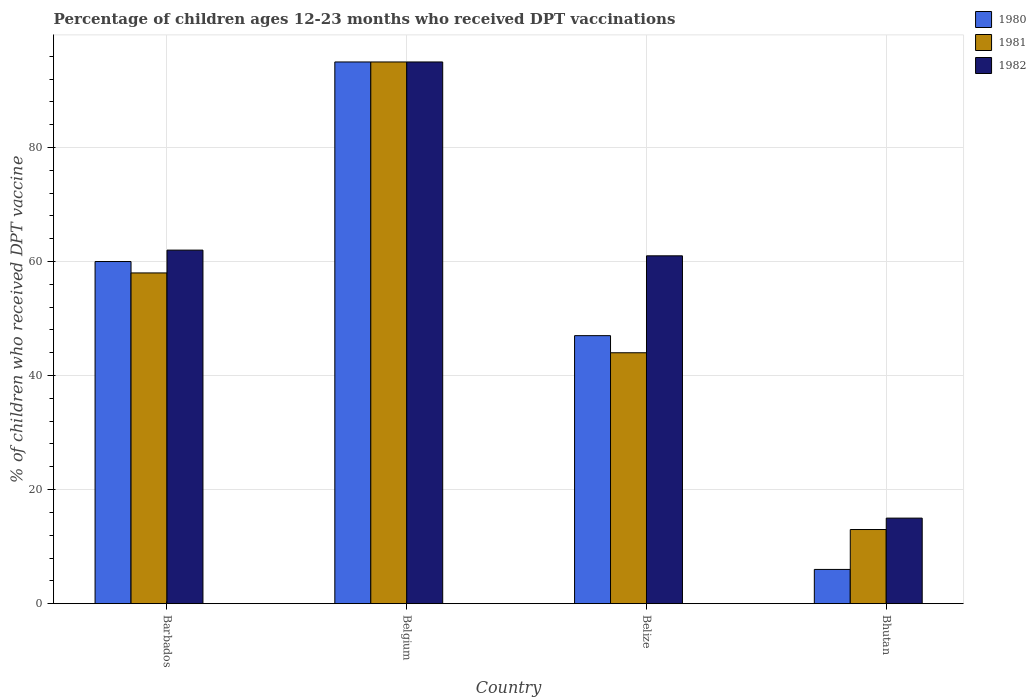How many different coloured bars are there?
Give a very brief answer. 3. Are the number of bars per tick equal to the number of legend labels?
Offer a very short reply. Yes. How many bars are there on the 3rd tick from the right?
Ensure brevity in your answer.  3. What is the label of the 1st group of bars from the left?
Offer a terse response. Barbados. What is the percentage of children who received DPT vaccination in 1981 in Belgium?
Offer a very short reply. 95. In which country was the percentage of children who received DPT vaccination in 1981 minimum?
Give a very brief answer. Bhutan. What is the total percentage of children who received DPT vaccination in 1981 in the graph?
Ensure brevity in your answer.  210. What is the difference between the percentage of children who received DPT vaccination in 1982 in Belgium and that in Bhutan?
Keep it short and to the point. 80. What is the difference between the percentage of children who received DPT vaccination in 1981 in Bhutan and the percentage of children who received DPT vaccination in 1980 in Belgium?
Provide a short and direct response. -82. What is the average percentage of children who received DPT vaccination in 1980 per country?
Make the answer very short. 52. What is the difference between the percentage of children who received DPT vaccination of/in 1981 and percentage of children who received DPT vaccination of/in 1982 in Belize?
Keep it short and to the point. -17. What is the ratio of the percentage of children who received DPT vaccination in 1982 in Barbados to that in Belgium?
Your answer should be very brief. 0.65. Is the percentage of children who received DPT vaccination in 1982 in Belgium less than that in Bhutan?
Provide a succinct answer. No. Is the difference between the percentage of children who received DPT vaccination in 1981 in Barbados and Bhutan greater than the difference between the percentage of children who received DPT vaccination in 1982 in Barbados and Bhutan?
Provide a short and direct response. No. What does the 2nd bar from the left in Bhutan represents?
Give a very brief answer. 1981. What does the 2nd bar from the right in Belize represents?
Ensure brevity in your answer.  1981. Is it the case that in every country, the sum of the percentage of children who received DPT vaccination in 1980 and percentage of children who received DPT vaccination in 1982 is greater than the percentage of children who received DPT vaccination in 1981?
Provide a short and direct response. Yes. How many bars are there?
Ensure brevity in your answer.  12. What is the difference between two consecutive major ticks on the Y-axis?
Provide a short and direct response. 20. Are the values on the major ticks of Y-axis written in scientific E-notation?
Offer a very short reply. No. Does the graph contain any zero values?
Provide a short and direct response. No. How are the legend labels stacked?
Make the answer very short. Vertical. What is the title of the graph?
Provide a succinct answer. Percentage of children ages 12-23 months who received DPT vaccinations. What is the label or title of the Y-axis?
Your response must be concise. % of children who received DPT vaccine. What is the % of children who received DPT vaccine in 1980 in Barbados?
Your answer should be very brief. 60. What is the % of children who received DPT vaccine in 1980 in Belgium?
Your response must be concise. 95. What is the % of children who received DPT vaccine of 1982 in Belgium?
Your response must be concise. 95. What is the % of children who received DPT vaccine in 1982 in Belize?
Provide a succinct answer. 61. What is the % of children who received DPT vaccine in 1980 in Bhutan?
Provide a succinct answer. 6. What is the % of children who received DPT vaccine in 1981 in Bhutan?
Offer a very short reply. 13. What is the % of children who received DPT vaccine in 1982 in Bhutan?
Provide a succinct answer. 15. Across all countries, what is the maximum % of children who received DPT vaccine in 1980?
Ensure brevity in your answer.  95. Across all countries, what is the minimum % of children who received DPT vaccine of 1980?
Ensure brevity in your answer.  6. Across all countries, what is the minimum % of children who received DPT vaccine of 1982?
Provide a succinct answer. 15. What is the total % of children who received DPT vaccine of 1980 in the graph?
Offer a terse response. 208. What is the total % of children who received DPT vaccine in 1981 in the graph?
Your response must be concise. 210. What is the total % of children who received DPT vaccine in 1982 in the graph?
Your answer should be compact. 233. What is the difference between the % of children who received DPT vaccine of 1980 in Barbados and that in Belgium?
Give a very brief answer. -35. What is the difference between the % of children who received DPT vaccine in 1981 in Barbados and that in Belgium?
Keep it short and to the point. -37. What is the difference between the % of children who received DPT vaccine of 1982 in Barbados and that in Belgium?
Provide a short and direct response. -33. What is the difference between the % of children who received DPT vaccine in 1980 in Barbados and that in Belize?
Provide a succinct answer. 13. What is the difference between the % of children who received DPT vaccine in 1981 in Barbados and that in Belize?
Keep it short and to the point. 14. What is the difference between the % of children who received DPT vaccine of 1980 in Barbados and that in Bhutan?
Make the answer very short. 54. What is the difference between the % of children who received DPT vaccine in 1981 in Belgium and that in Belize?
Provide a succinct answer. 51. What is the difference between the % of children who received DPT vaccine of 1980 in Belgium and that in Bhutan?
Make the answer very short. 89. What is the difference between the % of children who received DPT vaccine in 1981 in Belgium and that in Bhutan?
Your answer should be compact. 82. What is the difference between the % of children who received DPT vaccine of 1980 in Barbados and the % of children who received DPT vaccine of 1981 in Belgium?
Your response must be concise. -35. What is the difference between the % of children who received DPT vaccine of 1980 in Barbados and the % of children who received DPT vaccine of 1982 in Belgium?
Offer a terse response. -35. What is the difference between the % of children who received DPT vaccine of 1981 in Barbados and the % of children who received DPT vaccine of 1982 in Belgium?
Offer a very short reply. -37. What is the difference between the % of children who received DPT vaccine in 1980 in Barbados and the % of children who received DPT vaccine in 1981 in Belize?
Keep it short and to the point. 16. What is the difference between the % of children who received DPT vaccine of 1980 in Barbados and the % of children who received DPT vaccine of 1982 in Belize?
Offer a terse response. -1. What is the difference between the % of children who received DPT vaccine of 1981 in Barbados and the % of children who received DPT vaccine of 1982 in Belize?
Offer a very short reply. -3. What is the difference between the % of children who received DPT vaccine in 1980 in Belgium and the % of children who received DPT vaccine in 1982 in Belize?
Offer a terse response. 34. What is the difference between the % of children who received DPT vaccine in 1980 in Belgium and the % of children who received DPT vaccine in 1981 in Bhutan?
Keep it short and to the point. 82. What is the difference between the % of children who received DPT vaccine of 1981 in Belgium and the % of children who received DPT vaccine of 1982 in Bhutan?
Offer a terse response. 80. What is the difference between the % of children who received DPT vaccine of 1980 in Belize and the % of children who received DPT vaccine of 1982 in Bhutan?
Your answer should be very brief. 32. What is the difference between the % of children who received DPT vaccine in 1981 in Belize and the % of children who received DPT vaccine in 1982 in Bhutan?
Offer a terse response. 29. What is the average % of children who received DPT vaccine in 1980 per country?
Offer a terse response. 52. What is the average % of children who received DPT vaccine of 1981 per country?
Provide a succinct answer. 52.5. What is the average % of children who received DPT vaccine in 1982 per country?
Provide a succinct answer. 58.25. What is the difference between the % of children who received DPT vaccine in 1980 and % of children who received DPT vaccine in 1982 in Barbados?
Make the answer very short. -2. What is the difference between the % of children who received DPT vaccine in 1980 and % of children who received DPT vaccine in 1982 in Belgium?
Your answer should be compact. 0. What is the difference between the % of children who received DPT vaccine of 1981 and % of children who received DPT vaccine of 1982 in Belgium?
Keep it short and to the point. 0. What is the difference between the % of children who received DPT vaccine in 1980 and % of children who received DPT vaccine in 1982 in Belize?
Ensure brevity in your answer.  -14. What is the difference between the % of children who received DPT vaccine in 1981 and % of children who received DPT vaccine in 1982 in Belize?
Your answer should be very brief. -17. What is the difference between the % of children who received DPT vaccine of 1980 and % of children who received DPT vaccine of 1981 in Bhutan?
Provide a short and direct response. -7. What is the difference between the % of children who received DPT vaccine of 1981 and % of children who received DPT vaccine of 1982 in Bhutan?
Provide a short and direct response. -2. What is the ratio of the % of children who received DPT vaccine of 1980 in Barbados to that in Belgium?
Make the answer very short. 0.63. What is the ratio of the % of children who received DPT vaccine of 1981 in Barbados to that in Belgium?
Give a very brief answer. 0.61. What is the ratio of the % of children who received DPT vaccine of 1982 in Barbados to that in Belgium?
Keep it short and to the point. 0.65. What is the ratio of the % of children who received DPT vaccine in 1980 in Barbados to that in Belize?
Your response must be concise. 1.28. What is the ratio of the % of children who received DPT vaccine of 1981 in Barbados to that in Belize?
Your answer should be very brief. 1.32. What is the ratio of the % of children who received DPT vaccine in 1982 in Barbados to that in Belize?
Keep it short and to the point. 1.02. What is the ratio of the % of children who received DPT vaccine of 1981 in Barbados to that in Bhutan?
Provide a short and direct response. 4.46. What is the ratio of the % of children who received DPT vaccine of 1982 in Barbados to that in Bhutan?
Offer a very short reply. 4.13. What is the ratio of the % of children who received DPT vaccine of 1980 in Belgium to that in Belize?
Make the answer very short. 2.02. What is the ratio of the % of children who received DPT vaccine of 1981 in Belgium to that in Belize?
Offer a very short reply. 2.16. What is the ratio of the % of children who received DPT vaccine of 1982 in Belgium to that in Belize?
Offer a terse response. 1.56. What is the ratio of the % of children who received DPT vaccine in 1980 in Belgium to that in Bhutan?
Provide a short and direct response. 15.83. What is the ratio of the % of children who received DPT vaccine in 1981 in Belgium to that in Bhutan?
Offer a terse response. 7.31. What is the ratio of the % of children who received DPT vaccine in 1982 in Belgium to that in Bhutan?
Your answer should be very brief. 6.33. What is the ratio of the % of children who received DPT vaccine of 1980 in Belize to that in Bhutan?
Your answer should be compact. 7.83. What is the ratio of the % of children who received DPT vaccine in 1981 in Belize to that in Bhutan?
Your answer should be very brief. 3.38. What is the ratio of the % of children who received DPT vaccine of 1982 in Belize to that in Bhutan?
Ensure brevity in your answer.  4.07. What is the difference between the highest and the second highest % of children who received DPT vaccine of 1981?
Offer a terse response. 37. What is the difference between the highest and the second highest % of children who received DPT vaccine in 1982?
Make the answer very short. 33. What is the difference between the highest and the lowest % of children who received DPT vaccine of 1980?
Ensure brevity in your answer.  89. What is the difference between the highest and the lowest % of children who received DPT vaccine in 1982?
Offer a very short reply. 80. 